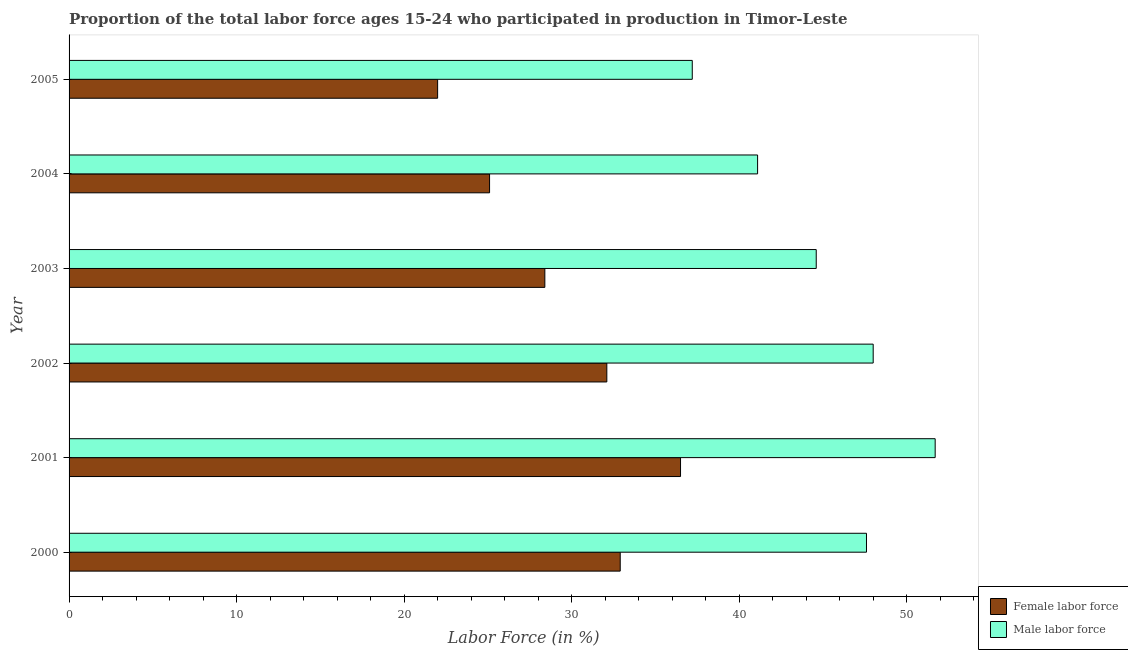How many different coloured bars are there?
Offer a terse response. 2. How many bars are there on the 3rd tick from the top?
Make the answer very short. 2. What is the percentage of male labour force in 2005?
Ensure brevity in your answer.  37.2. Across all years, what is the maximum percentage of female labor force?
Provide a short and direct response. 36.5. Across all years, what is the minimum percentage of male labour force?
Your answer should be compact. 37.2. What is the total percentage of female labor force in the graph?
Ensure brevity in your answer.  177. What is the difference between the percentage of female labor force in 2004 and the percentage of male labour force in 2005?
Your answer should be compact. -12.1. What is the average percentage of male labour force per year?
Offer a terse response. 45.03. In the year 2001, what is the difference between the percentage of male labour force and percentage of female labor force?
Give a very brief answer. 15.2. In how many years, is the percentage of male labour force greater than 46 %?
Provide a short and direct response. 3. What is the ratio of the percentage of male labour force in 2002 to that in 2005?
Your answer should be compact. 1.29. Is the difference between the percentage of male labour force in 2004 and 2005 greater than the difference between the percentage of female labor force in 2004 and 2005?
Offer a terse response. Yes. What is the difference between the highest and the lowest percentage of female labor force?
Your answer should be very brief. 14.5. In how many years, is the percentage of male labour force greater than the average percentage of male labour force taken over all years?
Your answer should be compact. 3. Is the sum of the percentage of male labour force in 2002 and 2005 greater than the maximum percentage of female labor force across all years?
Your answer should be very brief. Yes. What does the 2nd bar from the top in 2005 represents?
Your answer should be very brief. Female labor force. What does the 2nd bar from the bottom in 2005 represents?
Provide a succinct answer. Male labor force. How many bars are there?
Make the answer very short. 12. How many years are there in the graph?
Keep it short and to the point. 6. Does the graph contain any zero values?
Provide a succinct answer. No. Where does the legend appear in the graph?
Provide a succinct answer. Bottom right. How are the legend labels stacked?
Keep it short and to the point. Vertical. What is the title of the graph?
Offer a very short reply. Proportion of the total labor force ages 15-24 who participated in production in Timor-Leste. Does "GDP" appear as one of the legend labels in the graph?
Keep it short and to the point. No. What is the label or title of the X-axis?
Give a very brief answer. Labor Force (in %). What is the Labor Force (in %) in Female labor force in 2000?
Ensure brevity in your answer.  32.9. What is the Labor Force (in %) of Male labor force in 2000?
Provide a succinct answer. 47.6. What is the Labor Force (in %) of Female labor force in 2001?
Ensure brevity in your answer.  36.5. What is the Labor Force (in %) in Male labor force in 2001?
Make the answer very short. 51.7. What is the Labor Force (in %) of Female labor force in 2002?
Offer a very short reply. 32.1. What is the Labor Force (in %) in Male labor force in 2002?
Provide a succinct answer. 48. What is the Labor Force (in %) of Female labor force in 2003?
Provide a short and direct response. 28.4. What is the Labor Force (in %) of Male labor force in 2003?
Provide a succinct answer. 44.6. What is the Labor Force (in %) in Female labor force in 2004?
Make the answer very short. 25.1. What is the Labor Force (in %) in Male labor force in 2004?
Ensure brevity in your answer.  41.1. What is the Labor Force (in %) in Female labor force in 2005?
Give a very brief answer. 22. What is the Labor Force (in %) in Male labor force in 2005?
Keep it short and to the point. 37.2. Across all years, what is the maximum Labor Force (in %) in Female labor force?
Give a very brief answer. 36.5. Across all years, what is the maximum Labor Force (in %) of Male labor force?
Provide a short and direct response. 51.7. Across all years, what is the minimum Labor Force (in %) in Male labor force?
Offer a terse response. 37.2. What is the total Labor Force (in %) of Female labor force in the graph?
Offer a very short reply. 177. What is the total Labor Force (in %) in Male labor force in the graph?
Offer a very short reply. 270.2. What is the difference between the Labor Force (in %) of Female labor force in 2000 and that in 2002?
Give a very brief answer. 0.8. What is the difference between the Labor Force (in %) in Male labor force in 2000 and that in 2002?
Keep it short and to the point. -0.4. What is the difference between the Labor Force (in %) of Female labor force in 2000 and that in 2003?
Keep it short and to the point. 4.5. What is the difference between the Labor Force (in %) of Male labor force in 2000 and that in 2003?
Offer a very short reply. 3. What is the difference between the Labor Force (in %) in Female labor force in 2000 and that in 2005?
Give a very brief answer. 10.9. What is the difference between the Labor Force (in %) in Male labor force in 2001 and that in 2002?
Your answer should be compact. 3.7. What is the difference between the Labor Force (in %) in Female labor force in 2001 and that in 2003?
Your answer should be very brief. 8.1. What is the difference between the Labor Force (in %) of Male labor force in 2001 and that in 2003?
Make the answer very short. 7.1. What is the difference between the Labor Force (in %) of Male labor force in 2001 and that in 2004?
Your answer should be compact. 10.6. What is the difference between the Labor Force (in %) of Female labor force in 2001 and that in 2005?
Provide a short and direct response. 14.5. What is the difference between the Labor Force (in %) in Female labor force in 2002 and that in 2003?
Give a very brief answer. 3.7. What is the difference between the Labor Force (in %) in Male labor force in 2002 and that in 2003?
Ensure brevity in your answer.  3.4. What is the difference between the Labor Force (in %) of Female labor force in 2002 and that in 2004?
Offer a very short reply. 7. What is the difference between the Labor Force (in %) of Female labor force in 2003 and that in 2004?
Keep it short and to the point. 3.3. What is the difference between the Labor Force (in %) in Male labor force in 2003 and that in 2005?
Provide a short and direct response. 7.4. What is the difference between the Labor Force (in %) of Female labor force in 2000 and the Labor Force (in %) of Male labor force in 2001?
Your answer should be very brief. -18.8. What is the difference between the Labor Force (in %) of Female labor force in 2000 and the Labor Force (in %) of Male labor force in 2002?
Your answer should be very brief. -15.1. What is the difference between the Labor Force (in %) in Female labor force in 2000 and the Labor Force (in %) in Male labor force in 2004?
Give a very brief answer. -8.2. What is the difference between the Labor Force (in %) in Female labor force in 2001 and the Labor Force (in %) in Male labor force in 2002?
Provide a short and direct response. -11.5. What is the difference between the Labor Force (in %) of Female labor force in 2001 and the Labor Force (in %) of Male labor force in 2004?
Your answer should be compact. -4.6. What is the difference between the Labor Force (in %) in Female labor force in 2001 and the Labor Force (in %) in Male labor force in 2005?
Your response must be concise. -0.7. What is the difference between the Labor Force (in %) of Female labor force in 2002 and the Labor Force (in %) of Male labor force in 2003?
Offer a terse response. -12.5. What is the difference between the Labor Force (in %) in Female labor force in 2002 and the Labor Force (in %) in Male labor force in 2004?
Give a very brief answer. -9. What is the difference between the Labor Force (in %) in Female labor force in 2002 and the Labor Force (in %) in Male labor force in 2005?
Provide a short and direct response. -5.1. What is the difference between the Labor Force (in %) of Female labor force in 2003 and the Labor Force (in %) of Male labor force in 2004?
Keep it short and to the point. -12.7. What is the difference between the Labor Force (in %) in Female labor force in 2003 and the Labor Force (in %) in Male labor force in 2005?
Provide a succinct answer. -8.8. What is the difference between the Labor Force (in %) in Female labor force in 2004 and the Labor Force (in %) in Male labor force in 2005?
Provide a short and direct response. -12.1. What is the average Labor Force (in %) of Female labor force per year?
Your answer should be compact. 29.5. What is the average Labor Force (in %) in Male labor force per year?
Provide a short and direct response. 45.03. In the year 2000, what is the difference between the Labor Force (in %) in Female labor force and Labor Force (in %) in Male labor force?
Your answer should be compact. -14.7. In the year 2001, what is the difference between the Labor Force (in %) in Female labor force and Labor Force (in %) in Male labor force?
Offer a terse response. -15.2. In the year 2002, what is the difference between the Labor Force (in %) in Female labor force and Labor Force (in %) in Male labor force?
Offer a very short reply. -15.9. In the year 2003, what is the difference between the Labor Force (in %) of Female labor force and Labor Force (in %) of Male labor force?
Make the answer very short. -16.2. In the year 2005, what is the difference between the Labor Force (in %) of Female labor force and Labor Force (in %) of Male labor force?
Provide a succinct answer. -15.2. What is the ratio of the Labor Force (in %) of Female labor force in 2000 to that in 2001?
Keep it short and to the point. 0.9. What is the ratio of the Labor Force (in %) of Male labor force in 2000 to that in 2001?
Offer a very short reply. 0.92. What is the ratio of the Labor Force (in %) of Female labor force in 2000 to that in 2002?
Your answer should be compact. 1.02. What is the ratio of the Labor Force (in %) in Female labor force in 2000 to that in 2003?
Your answer should be compact. 1.16. What is the ratio of the Labor Force (in %) in Male labor force in 2000 to that in 2003?
Offer a terse response. 1.07. What is the ratio of the Labor Force (in %) of Female labor force in 2000 to that in 2004?
Provide a short and direct response. 1.31. What is the ratio of the Labor Force (in %) of Male labor force in 2000 to that in 2004?
Offer a very short reply. 1.16. What is the ratio of the Labor Force (in %) of Female labor force in 2000 to that in 2005?
Offer a very short reply. 1.5. What is the ratio of the Labor Force (in %) of Male labor force in 2000 to that in 2005?
Provide a succinct answer. 1.28. What is the ratio of the Labor Force (in %) in Female labor force in 2001 to that in 2002?
Offer a very short reply. 1.14. What is the ratio of the Labor Force (in %) of Male labor force in 2001 to that in 2002?
Your response must be concise. 1.08. What is the ratio of the Labor Force (in %) of Female labor force in 2001 to that in 2003?
Keep it short and to the point. 1.29. What is the ratio of the Labor Force (in %) of Male labor force in 2001 to that in 2003?
Your response must be concise. 1.16. What is the ratio of the Labor Force (in %) of Female labor force in 2001 to that in 2004?
Your answer should be compact. 1.45. What is the ratio of the Labor Force (in %) in Male labor force in 2001 to that in 2004?
Give a very brief answer. 1.26. What is the ratio of the Labor Force (in %) in Female labor force in 2001 to that in 2005?
Provide a short and direct response. 1.66. What is the ratio of the Labor Force (in %) in Male labor force in 2001 to that in 2005?
Your answer should be very brief. 1.39. What is the ratio of the Labor Force (in %) of Female labor force in 2002 to that in 2003?
Your answer should be very brief. 1.13. What is the ratio of the Labor Force (in %) in Male labor force in 2002 to that in 2003?
Offer a terse response. 1.08. What is the ratio of the Labor Force (in %) of Female labor force in 2002 to that in 2004?
Provide a succinct answer. 1.28. What is the ratio of the Labor Force (in %) in Male labor force in 2002 to that in 2004?
Keep it short and to the point. 1.17. What is the ratio of the Labor Force (in %) of Female labor force in 2002 to that in 2005?
Provide a succinct answer. 1.46. What is the ratio of the Labor Force (in %) in Male labor force in 2002 to that in 2005?
Keep it short and to the point. 1.29. What is the ratio of the Labor Force (in %) of Female labor force in 2003 to that in 2004?
Provide a short and direct response. 1.13. What is the ratio of the Labor Force (in %) in Male labor force in 2003 to that in 2004?
Offer a terse response. 1.09. What is the ratio of the Labor Force (in %) in Female labor force in 2003 to that in 2005?
Offer a very short reply. 1.29. What is the ratio of the Labor Force (in %) of Male labor force in 2003 to that in 2005?
Give a very brief answer. 1.2. What is the ratio of the Labor Force (in %) of Female labor force in 2004 to that in 2005?
Your answer should be compact. 1.14. What is the ratio of the Labor Force (in %) of Male labor force in 2004 to that in 2005?
Your answer should be very brief. 1.1. What is the difference between the highest and the second highest Labor Force (in %) of Female labor force?
Offer a terse response. 3.6. What is the difference between the highest and the second highest Labor Force (in %) in Male labor force?
Keep it short and to the point. 3.7. What is the difference between the highest and the lowest Labor Force (in %) of Male labor force?
Your answer should be very brief. 14.5. 